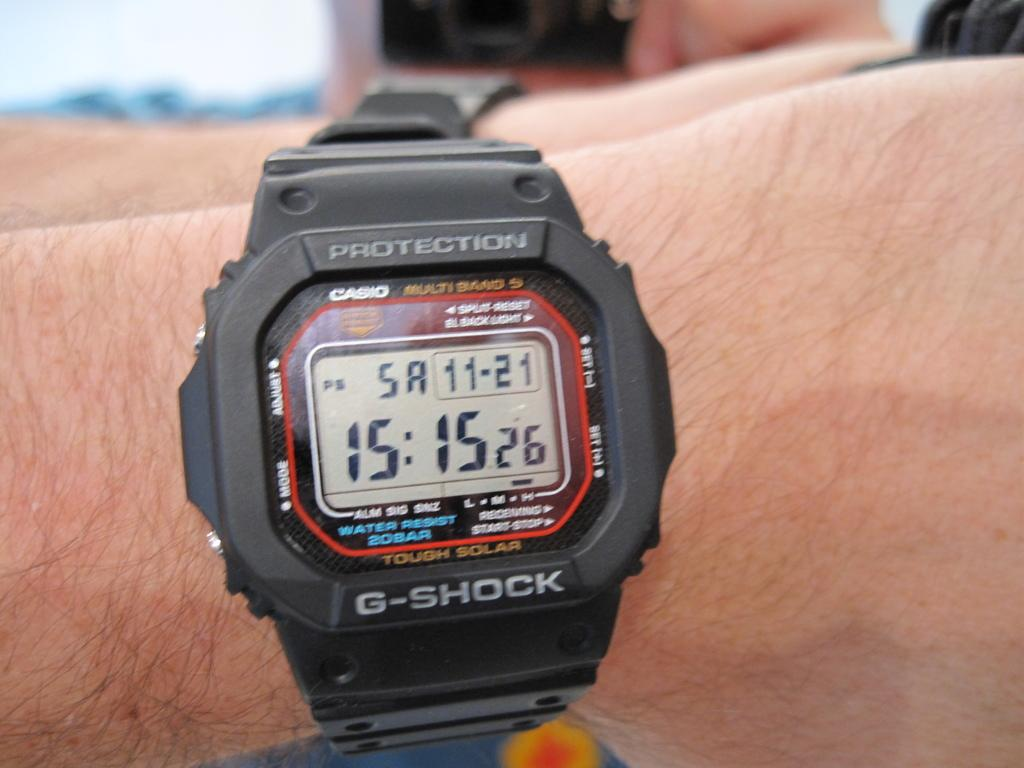<image>
Relay a brief, clear account of the picture shown. A Casio G-Shock digital watch showing that the time is 15:15:26 on Saturday November 21. 